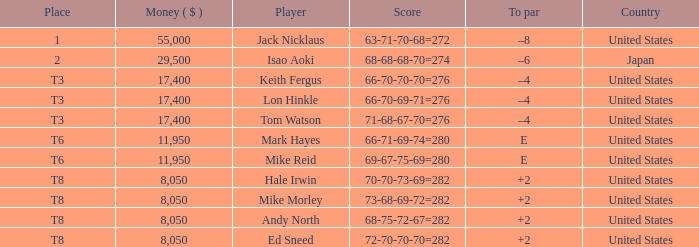Can you parse all the data within this table? {'header': ['Place', 'Money ( $ )', 'Player', 'Score', 'To par', 'Country'], 'rows': [['1', '55,000', 'Jack Nicklaus', '63-71-70-68=272', '–8', 'United States'], ['2', '29,500', 'Isao Aoki', '68-68-68-70=274', '–6', 'Japan'], ['T3', '17,400', 'Keith Fergus', '66-70-70-70=276', '–4', 'United States'], ['T3', '17,400', 'Lon Hinkle', '66-70-69-71=276', '–4', 'United States'], ['T3', '17,400', 'Tom Watson', '71-68-67-70=276', '–4', 'United States'], ['T6', '11,950', 'Mark Hayes', '66-71-69-74=280', 'E', 'United States'], ['T6', '11,950', 'Mike Reid', '69-67-75-69=280', 'E', 'United States'], ['T8', '8,050', 'Hale Irwin', '70-70-73-69=282', '+2', 'United States'], ['T8', '8,050', 'Mike Morley', '73-68-69-72=282', '+2', 'United States'], ['T8', '8,050', 'Andy North', '68-75-72-67=282', '+2', 'United States'], ['T8', '8,050', 'Ed Sneed', '72-70-70-70=282', '+2', 'United States']]} What to par is located in the united states and has the player by the name of hale irwin? 2.0. 